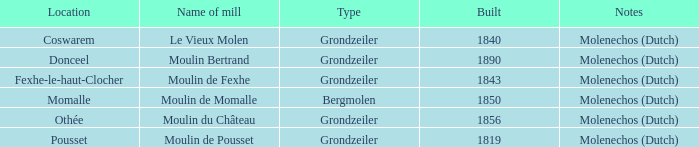Where can the moulin bertrand mill be found? Donceel. 